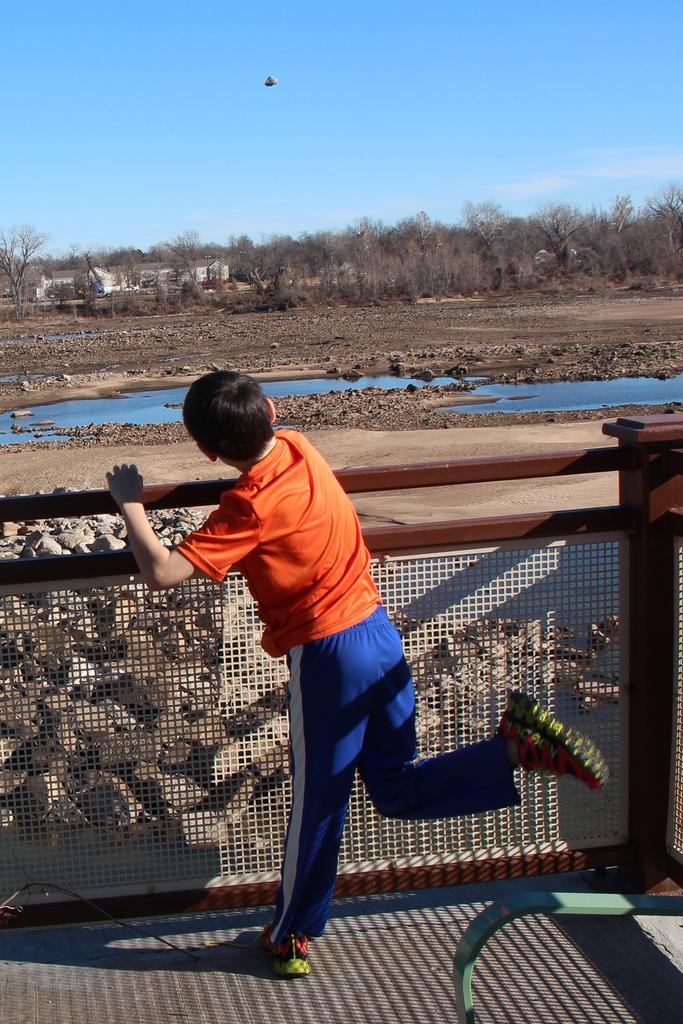In one or two sentences, can you explain what this image depicts? In this picture I can see a boy standing near the railing, in the middle there is water. I can see few trees in the background, at the top there is the sky. 